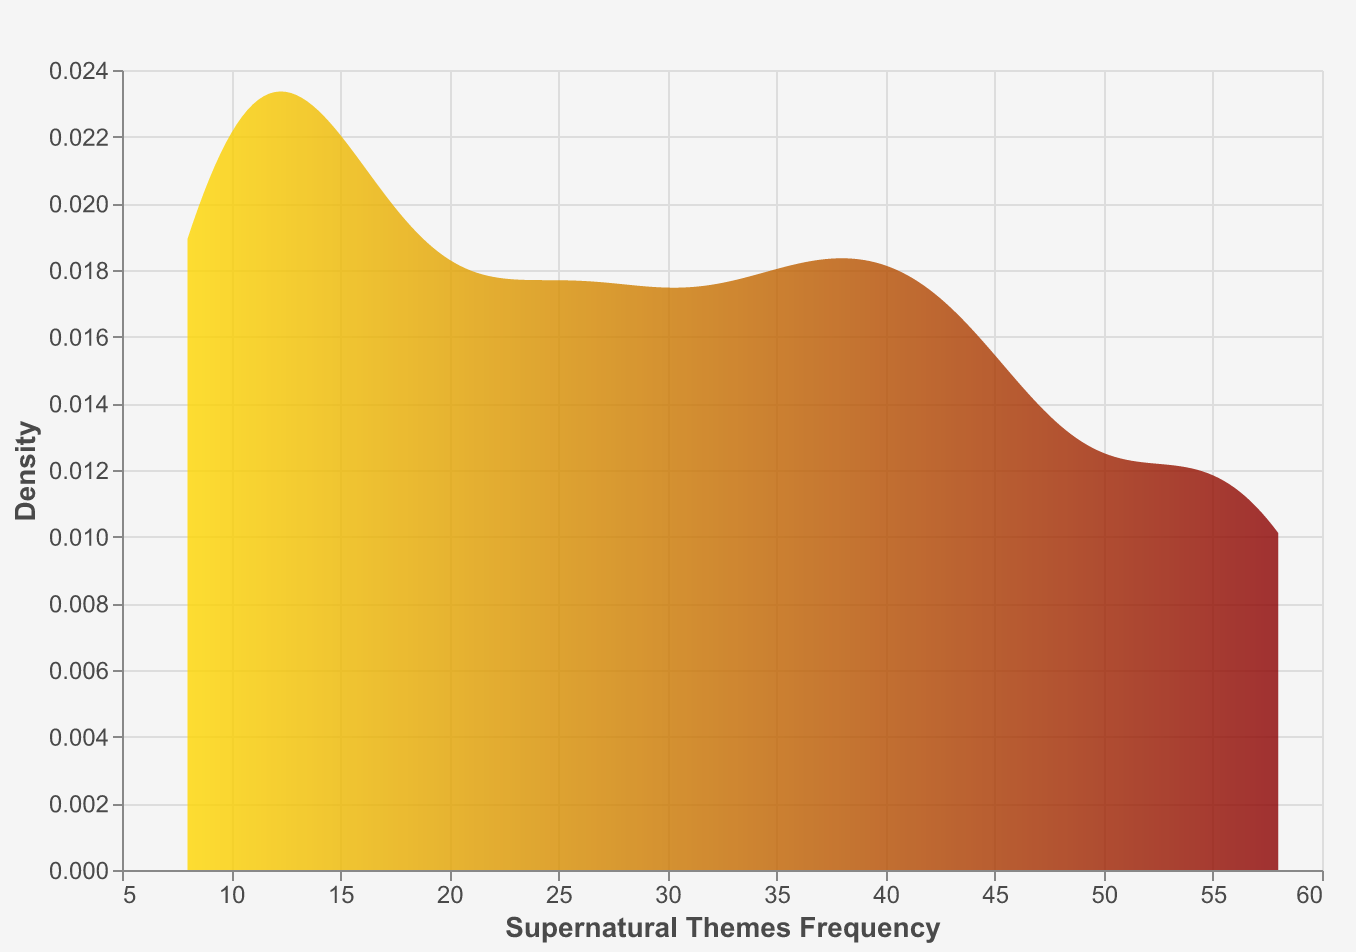What is the title of the figure? The title can be found at the top of the figure, which states "Frequency of Supernatural Themes in Classic Literature."
Answer: Frequency of Supernatural Themes in Classic Literature What does the y-axis represent? The y-axis label is "Density," indicating it represents the density distribution of the supernatural themes frequency within the data.
Answer: Density What is the color gradient used in the plot? The color gradient starts from gold and transitions to dark red, as observed from left to right on the area plot.
Answer: Gold to dark red Which novel has the highest frequency of supernatural themes? By referring to the data, "Dracula" by Bram Stoker has the highest frequency with a value of 58.
Answer: Dracula Which novel has the lowest frequency of supernatural themes? According to the data, "Gulliver's Travels" by Jonathan Swift has the lowest frequency with a value of 8.
Answer: Gulliver's Travels What's the range of the x-axis? The x-axis represents "Supernatural Themes Frequency," and it spans from approximately 0 to 60 based on the labeling.
Answer: 0 to 60 What's the average frequency of supernatural themes across all the novels? Sum all the frequencies (42 + 58 + 45 + 37 + 28 + 15 + 53 + 12 + 8 + 34 + 20 + 10 + 25) and divide by the number of novels (13). The sum is 387, so the average is 387 / 13 = 29.77.
Answer: 29.77 How many novels have a frequency of more than 40? Examine the data to identify novels with a frequency above 40: "Frankenstein" (42), "Dracula" (58), "The Turn of the Screw" (45), and "The Strange Case of Dr Jekyll and Mr Hyde" (53) – totaling 4 novels.
Answer: 4 What does the peak of the density curve suggest about the frequencies of supernatural themes? The peak of the density curve corresponds to the most common range of supernatural theme frequencies, suggesting most novels have frequencies around this high-density area.
Answer: Common frequency range Which novel's frequency is closest to the median of the dataset, and what is this frequency? To find the median, list the frequencies in ascending order (8, 10, 12, 15, 20, 25, 28, 34, 37, 42, 45, 53, 58). The middle value (7th in this list) is the median, which is 28. The novel with this frequency is "Wuthering Heights."
Answer: Wuthering Heights, 28 